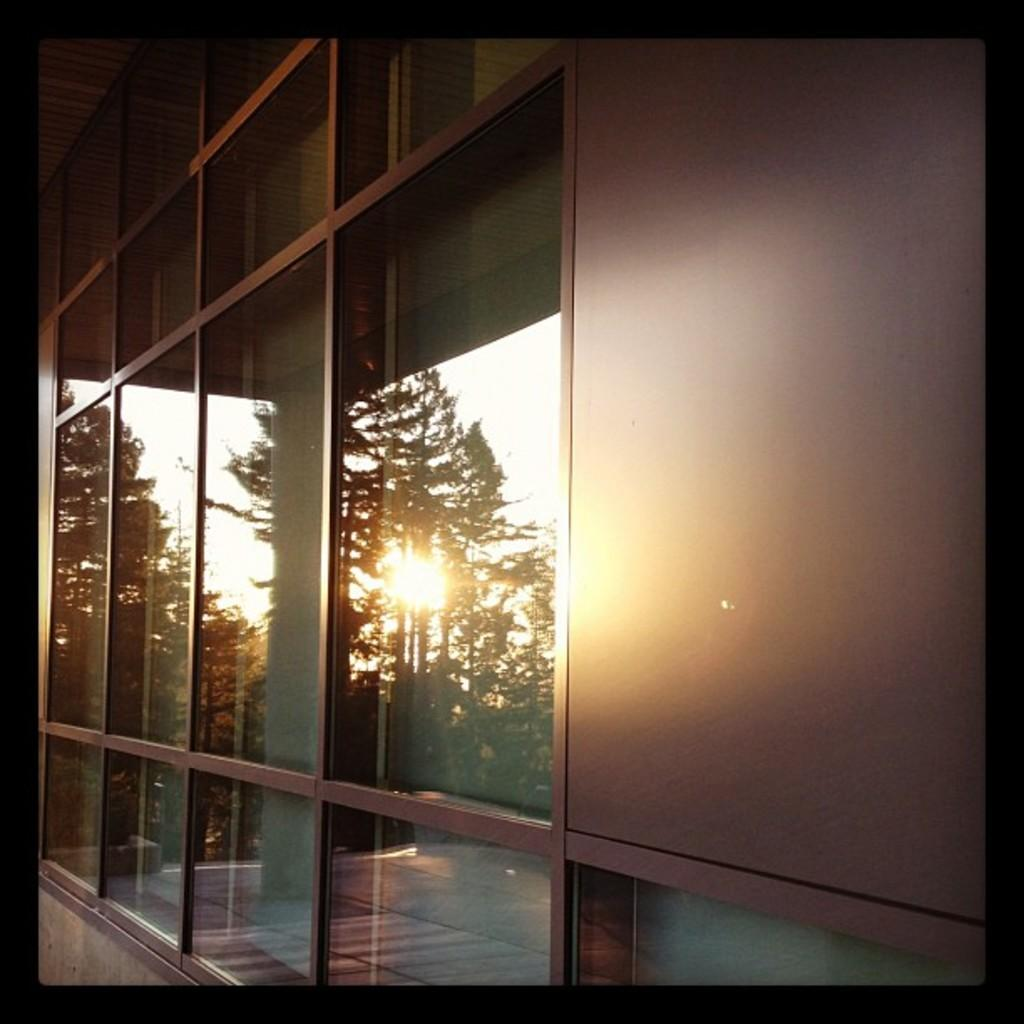What type of structure is visible in the image? There is a building wall in the image. What feature can be seen on the building wall? The building wall has a glass panel. What is depicted within the glass panel? The glass panel contains an image of trees. What additional element is included in the image of trees? The image of trees includes the sun. How many visitors are present in the image? There is no indication of visitors in the image; it primarily features a building wall with a glass panel containing an image of trees. 